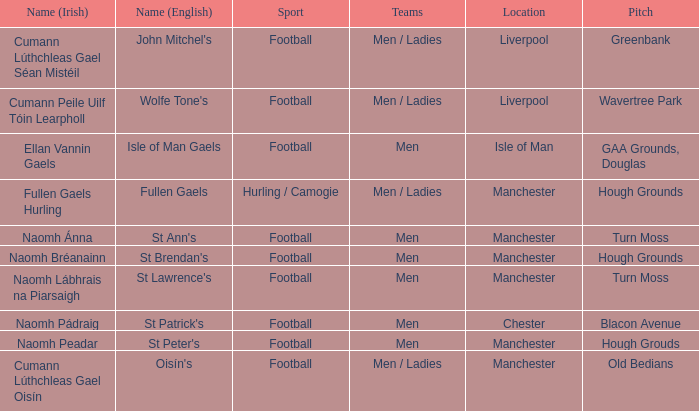What is the name of the place in chester referred to in english? St Patrick's. 